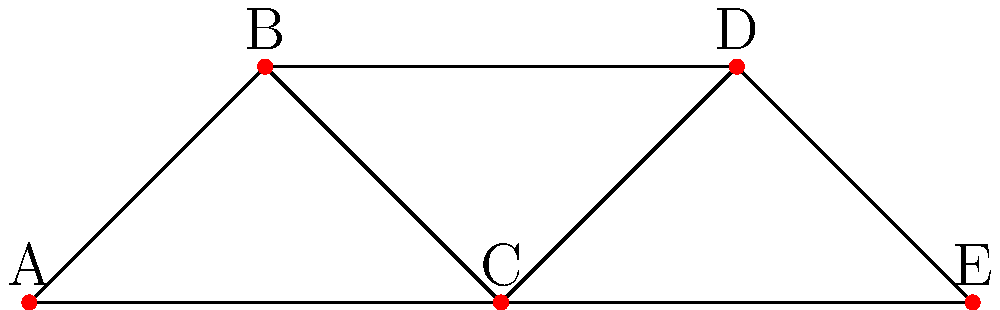In the given network representing international trade routes between countries A, B, C, D, and E, what is the minimum number of trade routes that need to be disrupted to completely isolate country C from all other countries? To solve this problem, we need to analyze the connectivity of country C in the network:

1. Identify all trade routes connected to country C:
   - C is connected to A
   - C is connected to B
   - C is connected to D
   - C is connected to E

2. Count the number of direct connections:
   Country C has 4 direct connections.

3. Understand the concept of minimum cut:
   The minimum number of edges that need to be removed to disconnect a node from the rest of the network is equal to the number of its direct connections.

4. Apply the concept to our scenario:
   To isolate country C, we need to disrupt all of its direct connections.

5. Conclusion:
   The minimum number of trade routes that need to be disrupted to completely isolate country C is equal to its number of direct connections, which is 4.

This analysis is relevant to international affairs as it demonstrates the concept of economic interdependence and vulnerability in global trade networks.
Answer: 4 